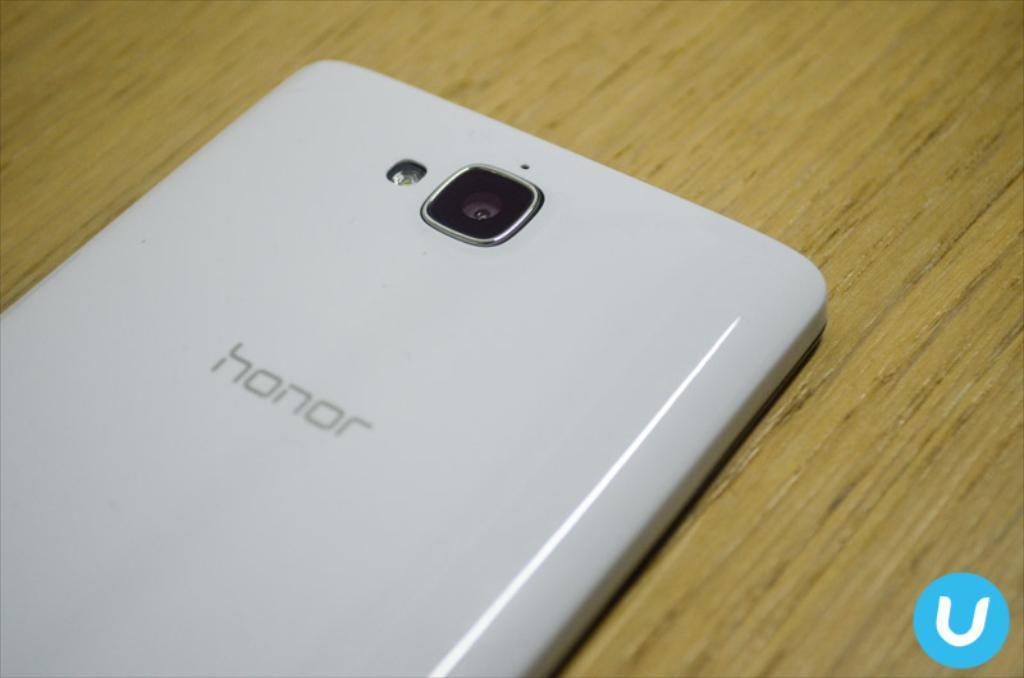Describe this image in one or two sentences. In this image we can see a mobile on the wooden surface. There is a watermark in the right bottom of the image. 